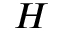Convert formula to latex. <formula><loc_0><loc_0><loc_500><loc_500>H</formula> 